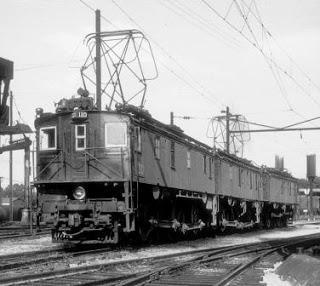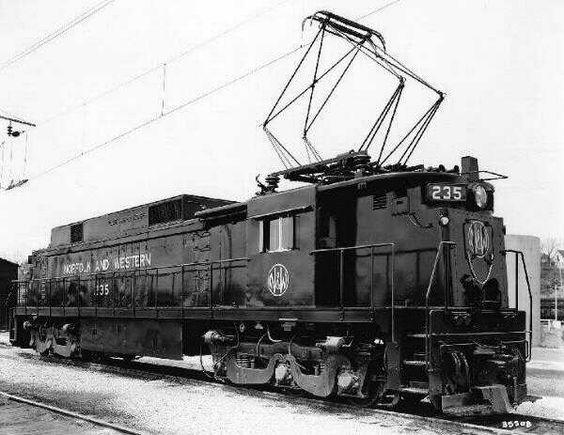The first image is the image on the left, the second image is the image on the right. For the images displayed, is the sentence "There are two trains in total traveling in opposite direction." factually correct? Answer yes or no. Yes. The first image is the image on the left, the second image is the image on the right. Examine the images to the left and right. Is the description "The trains in the left and right images head away from each other, in opposite directions." accurate? Answer yes or no. Yes. 